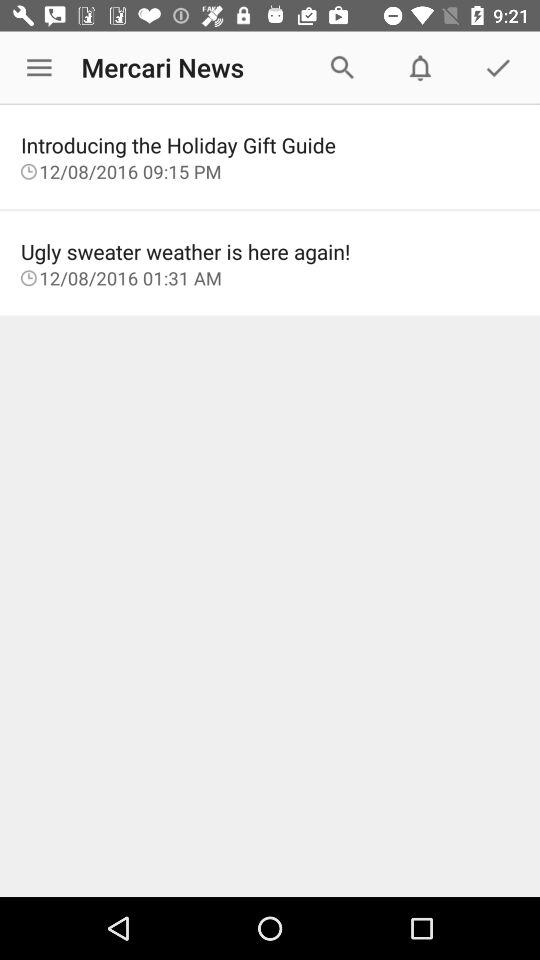At what time is the news "ugly sweater weather is here again!" updated? The news "ugly sweater weather is here again!" was updated at 01:31 AM. 